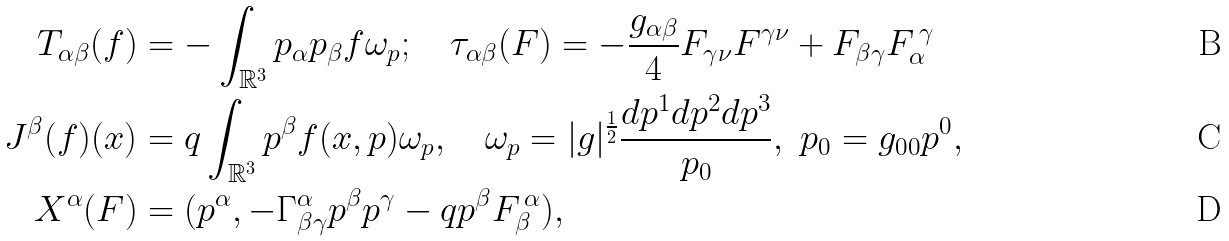<formula> <loc_0><loc_0><loc_500><loc_500>T _ { \alpha \beta } ( f ) & = - \int _ { \mathbb { R } ^ { 3 } } p _ { \alpha } p _ { \beta } f \omega _ { p } ; \quad \tau _ { \alpha \beta } ( F ) = - \frac { g _ { \alpha \beta } } { 4 } F _ { \gamma \nu } F ^ { \gamma \nu } + F _ { \beta \gamma } F _ { \alpha } ^ { \, \gamma } \\ J ^ { \beta } ( f ) ( x ) & = q \int _ { \mathbb { R } ^ { 3 } } p ^ { \beta } f ( x , p ) \omega _ { p } , \quad \omega _ { p } = | g | ^ { \frac { 1 } { 2 } } \frac { d p ^ { 1 } d p ^ { 2 } d p ^ { 3 } } { p _ { 0 } } , \ p _ { 0 } = g _ { 0 0 } p ^ { 0 } , \\ X ^ { \alpha } ( F ) & = ( p ^ { \alpha } , - \Gamma _ { \beta \gamma } ^ { \alpha } p ^ { \beta } p ^ { \gamma } - q p ^ { \beta } F _ { \beta } ^ { \, \alpha } ) ,</formula> 